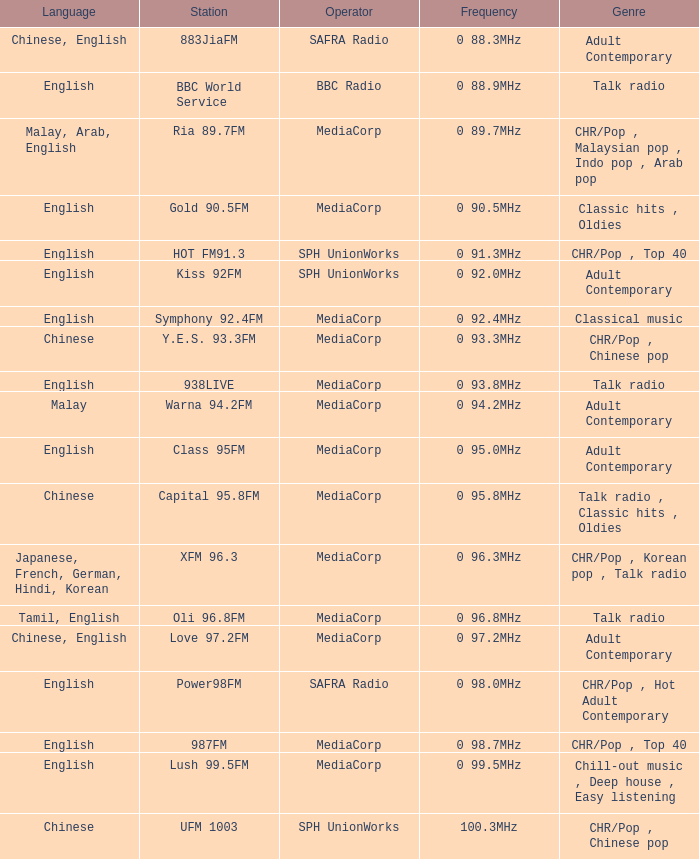Which station is operated by BBC Radio under the talk radio genre? BBC World Service. 